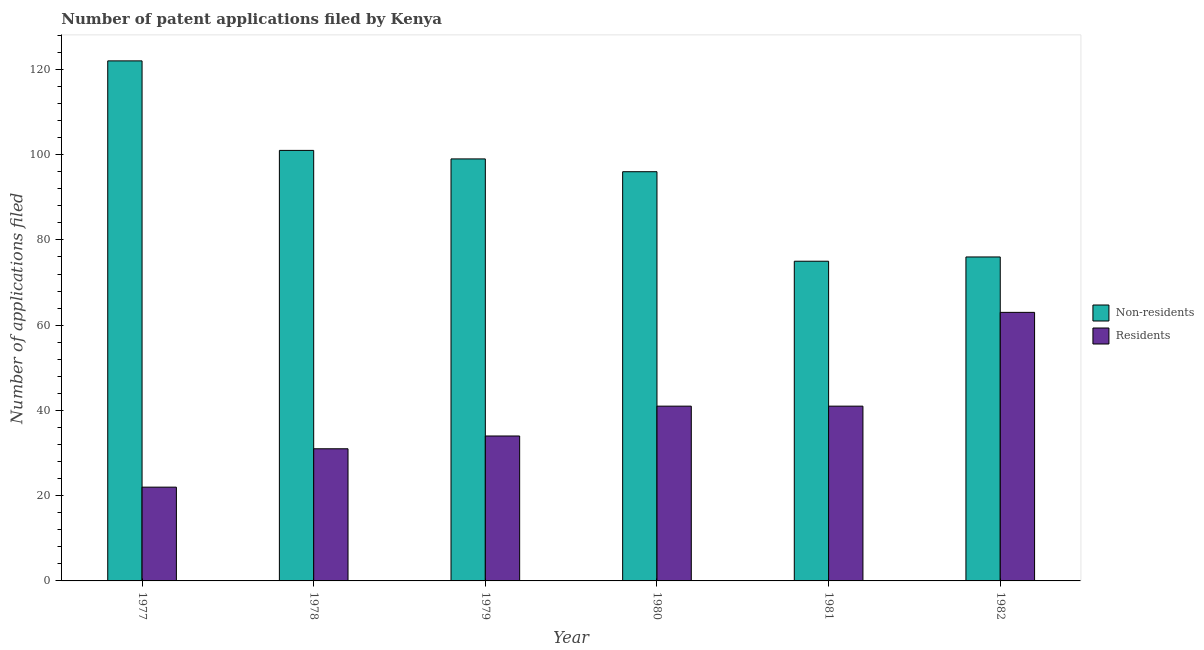How many different coloured bars are there?
Your answer should be compact. 2. Are the number of bars on each tick of the X-axis equal?
Give a very brief answer. Yes. How many bars are there on the 1st tick from the right?
Ensure brevity in your answer.  2. What is the number of patent applications by residents in 1979?
Provide a succinct answer. 34. Across all years, what is the maximum number of patent applications by non residents?
Your answer should be compact. 122. Across all years, what is the minimum number of patent applications by non residents?
Provide a succinct answer. 75. In which year was the number of patent applications by residents maximum?
Your answer should be compact. 1982. In which year was the number of patent applications by residents minimum?
Ensure brevity in your answer.  1977. What is the total number of patent applications by residents in the graph?
Your response must be concise. 232. What is the difference between the number of patent applications by non residents in 1977 and that in 1978?
Offer a terse response. 21. What is the difference between the number of patent applications by residents in 1977 and the number of patent applications by non residents in 1982?
Your response must be concise. -41. What is the average number of patent applications by residents per year?
Your answer should be compact. 38.67. What is the ratio of the number of patent applications by residents in 1977 to that in 1978?
Provide a succinct answer. 0.71. What is the difference between the highest and the second highest number of patent applications by residents?
Make the answer very short. 22. What is the difference between the highest and the lowest number of patent applications by residents?
Ensure brevity in your answer.  41. In how many years, is the number of patent applications by non residents greater than the average number of patent applications by non residents taken over all years?
Give a very brief answer. 4. What does the 1st bar from the left in 1980 represents?
Offer a terse response. Non-residents. What does the 1st bar from the right in 1978 represents?
Offer a very short reply. Residents. How many bars are there?
Keep it short and to the point. 12. How many years are there in the graph?
Provide a succinct answer. 6. What is the difference between two consecutive major ticks on the Y-axis?
Give a very brief answer. 20. Are the values on the major ticks of Y-axis written in scientific E-notation?
Give a very brief answer. No. Does the graph contain any zero values?
Your response must be concise. No. What is the title of the graph?
Give a very brief answer. Number of patent applications filed by Kenya. Does "Enforce a contract" appear as one of the legend labels in the graph?
Your answer should be compact. No. What is the label or title of the X-axis?
Offer a terse response. Year. What is the label or title of the Y-axis?
Your answer should be compact. Number of applications filed. What is the Number of applications filed in Non-residents in 1977?
Make the answer very short. 122. What is the Number of applications filed of Non-residents in 1978?
Provide a succinct answer. 101. What is the Number of applications filed of Residents in 1978?
Keep it short and to the point. 31. What is the Number of applications filed in Non-residents in 1979?
Offer a very short reply. 99. What is the Number of applications filed of Residents in 1979?
Offer a terse response. 34. What is the Number of applications filed of Non-residents in 1980?
Your response must be concise. 96. What is the Number of applications filed in Non-residents in 1981?
Provide a succinct answer. 75. What is the Number of applications filed in Non-residents in 1982?
Provide a short and direct response. 76. Across all years, what is the maximum Number of applications filed of Non-residents?
Your answer should be very brief. 122. Across all years, what is the maximum Number of applications filed of Residents?
Offer a very short reply. 63. Across all years, what is the minimum Number of applications filed of Non-residents?
Offer a terse response. 75. What is the total Number of applications filed in Non-residents in the graph?
Offer a terse response. 569. What is the total Number of applications filed in Residents in the graph?
Provide a succinct answer. 232. What is the difference between the Number of applications filed in Non-residents in 1977 and that in 1978?
Your response must be concise. 21. What is the difference between the Number of applications filed of Residents in 1977 and that in 1978?
Make the answer very short. -9. What is the difference between the Number of applications filed in Non-residents in 1977 and that in 1980?
Your answer should be compact. 26. What is the difference between the Number of applications filed in Non-residents in 1977 and that in 1982?
Your response must be concise. 46. What is the difference between the Number of applications filed in Residents in 1977 and that in 1982?
Your answer should be very brief. -41. What is the difference between the Number of applications filed in Non-residents in 1978 and that in 1979?
Offer a very short reply. 2. What is the difference between the Number of applications filed in Residents in 1978 and that in 1979?
Ensure brevity in your answer.  -3. What is the difference between the Number of applications filed in Non-residents in 1978 and that in 1980?
Give a very brief answer. 5. What is the difference between the Number of applications filed of Residents in 1978 and that in 1980?
Provide a succinct answer. -10. What is the difference between the Number of applications filed of Non-residents in 1978 and that in 1981?
Offer a very short reply. 26. What is the difference between the Number of applications filed in Residents in 1978 and that in 1982?
Your answer should be compact. -32. What is the difference between the Number of applications filed in Non-residents in 1979 and that in 1980?
Give a very brief answer. 3. What is the difference between the Number of applications filed in Non-residents in 1979 and that in 1981?
Your answer should be very brief. 24. What is the difference between the Number of applications filed in Residents in 1979 and that in 1981?
Offer a terse response. -7. What is the difference between the Number of applications filed in Residents in 1979 and that in 1982?
Make the answer very short. -29. What is the difference between the Number of applications filed of Residents in 1980 and that in 1981?
Your response must be concise. 0. What is the difference between the Number of applications filed in Residents in 1980 and that in 1982?
Keep it short and to the point. -22. What is the difference between the Number of applications filed of Residents in 1981 and that in 1982?
Offer a very short reply. -22. What is the difference between the Number of applications filed of Non-residents in 1977 and the Number of applications filed of Residents in 1978?
Offer a very short reply. 91. What is the difference between the Number of applications filed of Non-residents in 1977 and the Number of applications filed of Residents in 1979?
Offer a terse response. 88. What is the difference between the Number of applications filed of Non-residents in 1977 and the Number of applications filed of Residents in 1980?
Make the answer very short. 81. What is the difference between the Number of applications filed of Non-residents in 1977 and the Number of applications filed of Residents in 1982?
Your answer should be compact. 59. What is the difference between the Number of applications filed in Non-residents in 1978 and the Number of applications filed in Residents in 1979?
Offer a very short reply. 67. What is the difference between the Number of applications filed in Non-residents in 1978 and the Number of applications filed in Residents in 1980?
Your answer should be compact. 60. What is the difference between the Number of applications filed in Non-residents in 1978 and the Number of applications filed in Residents in 1982?
Provide a short and direct response. 38. What is the difference between the Number of applications filed in Non-residents in 1979 and the Number of applications filed in Residents in 1981?
Make the answer very short. 58. What is the difference between the Number of applications filed of Non-residents in 1981 and the Number of applications filed of Residents in 1982?
Ensure brevity in your answer.  12. What is the average Number of applications filed in Non-residents per year?
Offer a terse response. 94.83. What is the average Number of applications filed in Residents per year?
Your response must be concise. 38.67. In the year 1978, what is the difference between the Number of applications filed of Non-residents and Number of applications filed of Residents?
Make the answer very short. 70. In the year 1979, what is the difference between the Number of applications filed in Non-residents and Number of applications filed in Residents?
Provide a short and direct response. 65. What is the ratio of the Number of applications filed in Non-residents in 1977 to that in 1978?
Offer a terse response. 1.21. What is the ratio of the Number of applications filed in Residents in 1977 to that in 1978?
Offer a very short reply. 0.71. What is the ratio of the Number of applications filed of Non-residents in 1977 to that in 1979?
Your answer should be very brief. 1.23. What is the ratio of the Number of applications filed in Residents in 1977 to that in 1979?
Your answer should be very brief. 0.65. What is the ratio of the Number of applications filed in Non-residents in 1977 to that in 1980?
Give a very brief answer. 1.27. What is the ratio of the Number of applications filed in Residents in 1977 to that in 1980?
Your answer should be compact. 0.54. What is the ratio of the Number of applications filed in Non-residents in 1977 to that in 1981?
Offer a terse response. 1.63. What is the ratio of the Number of applications filed in Residents in 1977 to that in 1981?
Your answer should be very brief. 0.54. What is the ratio of the Number of applications filed in Non-residents in 1977 to that in 1982?
Provide a short and direct response. 1.61. What is the ratio of the Number of applications filed of Residents in 1977 to that in 1982?
Your answer should be very brief. 0.35. What is the ratio of the Number of applications filed of Non-residents in 1978 to that in 1979?
Your answer should be compact. 1.02. What is the ratio of the Number of applications filed in Residents in 1978 to that in 1979?
Your answer should be compact. 0.91. What is the ratio of the Number of applications filed of Non-residents in 1978 to that in 1980?
Offer a terse response. 1.05. What is the ratio of the Number of applications filed of Residents in 1978 to that in 1980?
Provide a short and direct response. 0.76. What is the ratio of the Number of applications filed of Non-residents in 1978 to that in 1981?
Offer a very short reply. 1.35. What is the ratio of the Number of applications filed of Residents in 1978 to that in 1981?
Provide a succinct answer. 0.76. What is the ratio of the Number of applications filed in Non-residents in 1978 to that in 1982?
Your answer should be compact. 1.33. What is the ratio of the Number of applications filed of Residents in 1978 to that in 1982?
Offer a very short reply. 0.49. What is the ratio of the Number of applications filed in Non-residents in 1979 to that in 1980?
Your answer should be compact. 1.03. What is the ratio of the Number of applications filed of Residents in 1979 to that in 1980?
Give a very brief answer. 0.83. What is the ratio of the Number of applications filed of Non-residents in 1979 to that in 1981?
Make the answer very short. 1.32. What is the ratio of the Number of applications filed of Residents in 1979 to that in 1981?
Offer a terse response. 0.83. What is the ratio of the Number of applications filed in Non-residents in 1979 to that in 1982?
Make the answer very short. 1.3. What is the ratio of the Number of applications filed in Residents in 1979 to that in 1982?
Provide a short and direct response. 0.54. What is the ratio of the Number of applications filed in Non-residents in 1980 to that in 1981?
Your answer should be compact. 1.28. What is the ratio of the Number of applications filed in Residents in 1980 to that in 1981?
Your answer should be very brief. 1. What is the ratio of the Number of applications filed of Non-residents in 1980 to that in 1982?
Give a very brief answer. 1.26. What is the ratio of the Number of applications filed of Residents in 1980 to that in 1982?
Keep it short and to the point. 0.65. What is the ratio of the Number of applications filed of Non-residents in 1981 to that in 1982?
Give a very brief answer. 0.99. What is the ratio of the Number of applications filed in Residents in 1981 to that in 1982?
Give a very brief answer. 0.65. What is the difference between the highest and the second highest Number of applications filed in Non-residents?
Your answer should be compact. 21. What is the difference between the highest and the lowest Number of applications filed of Non-residents?
Your response must be concise. 47. What is the difference between the highest and the lowest Number of applications filed of Residents?
Ensure brevity in your answer.  41. 